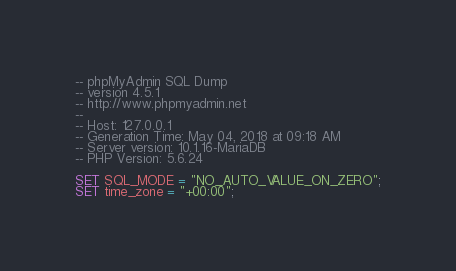<code> <loc_0><loc_0><loc_500><loc_500><_SQL_>-- phpMyAdmin SQL Dump
-- version 4.5.1
-- http://www.phpmyadmin.net
--
-- Host: 127.0.0.1
-- Generation Time: May 04, 2018 at 09:18 AM
-- Server version: 10.1.16-MariaDB
-- PHP Version: 5.6.24

SET SQL_MODE = "NO_AUTO_VALUE_ON_ZERO";
SET time_zone = "+00:00";

</code> 